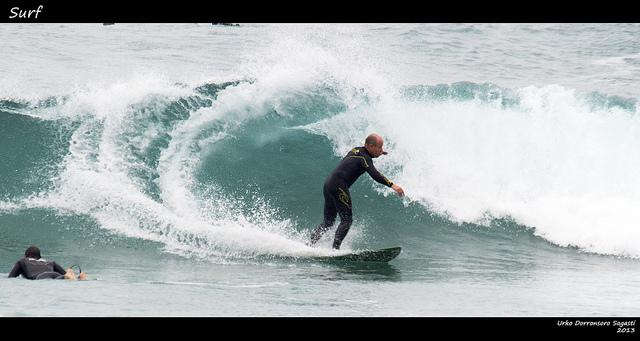What type of hairline does the standing man have? receding 